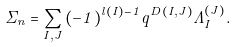<formula> <loc_0><loc_0><loc_500><loc_500>\Sigma _ { n } = \sum _ { I , J } { ( - 1 ) ^ { l ( I ) - 1 } q ^ { D ( I , J ) } \Lambda _ { I } ^ { ( J ) } } .</formula> 